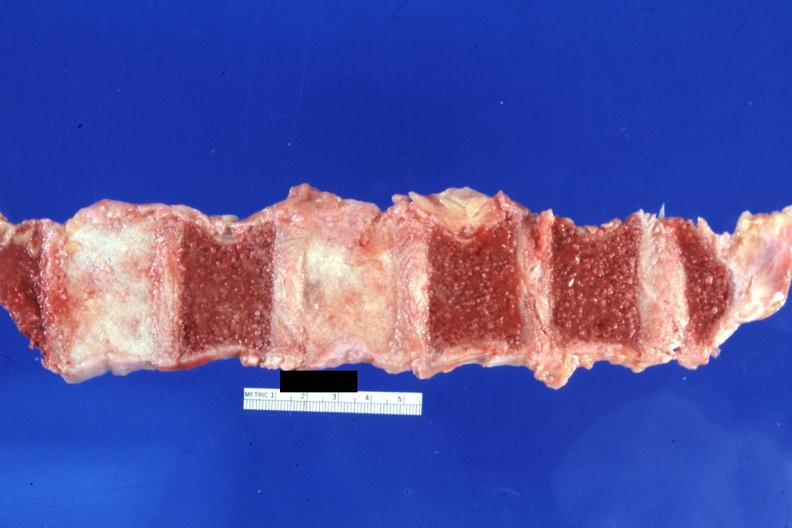s joints present?
Answer the question using a single word or phrase. Yes 